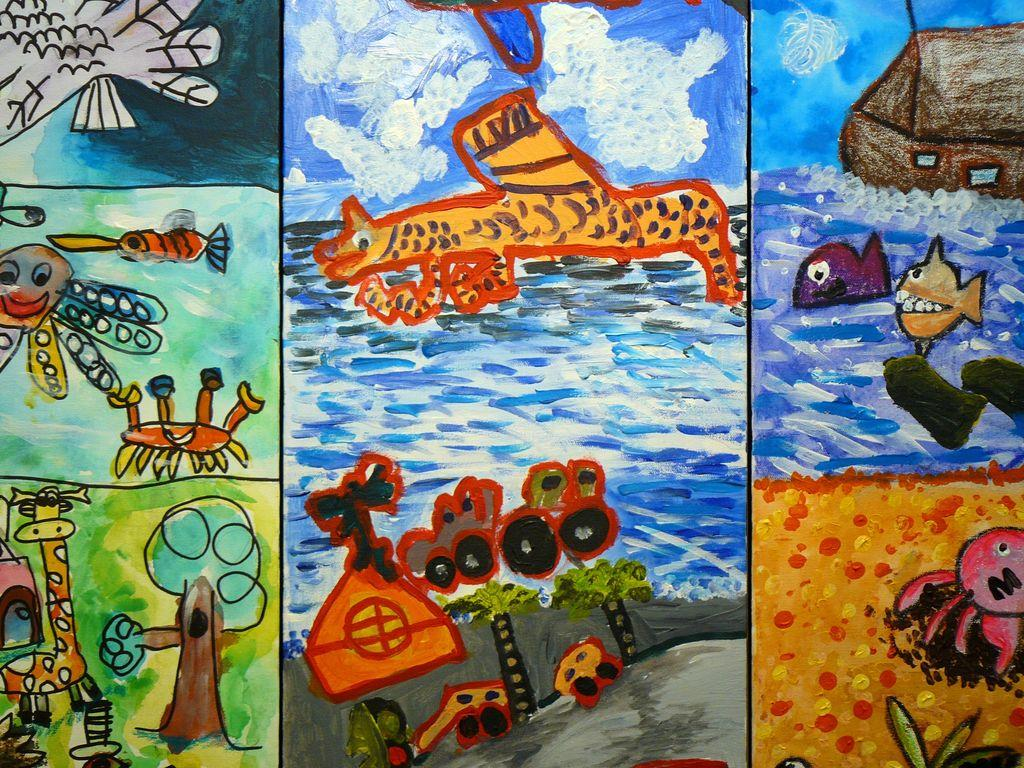What is the main subject of the image? There is a painting in the image. Can you tell me how many times the cat sneezes in the painting? There is no cat present in the image, and therefore no sneezing can be observed. 